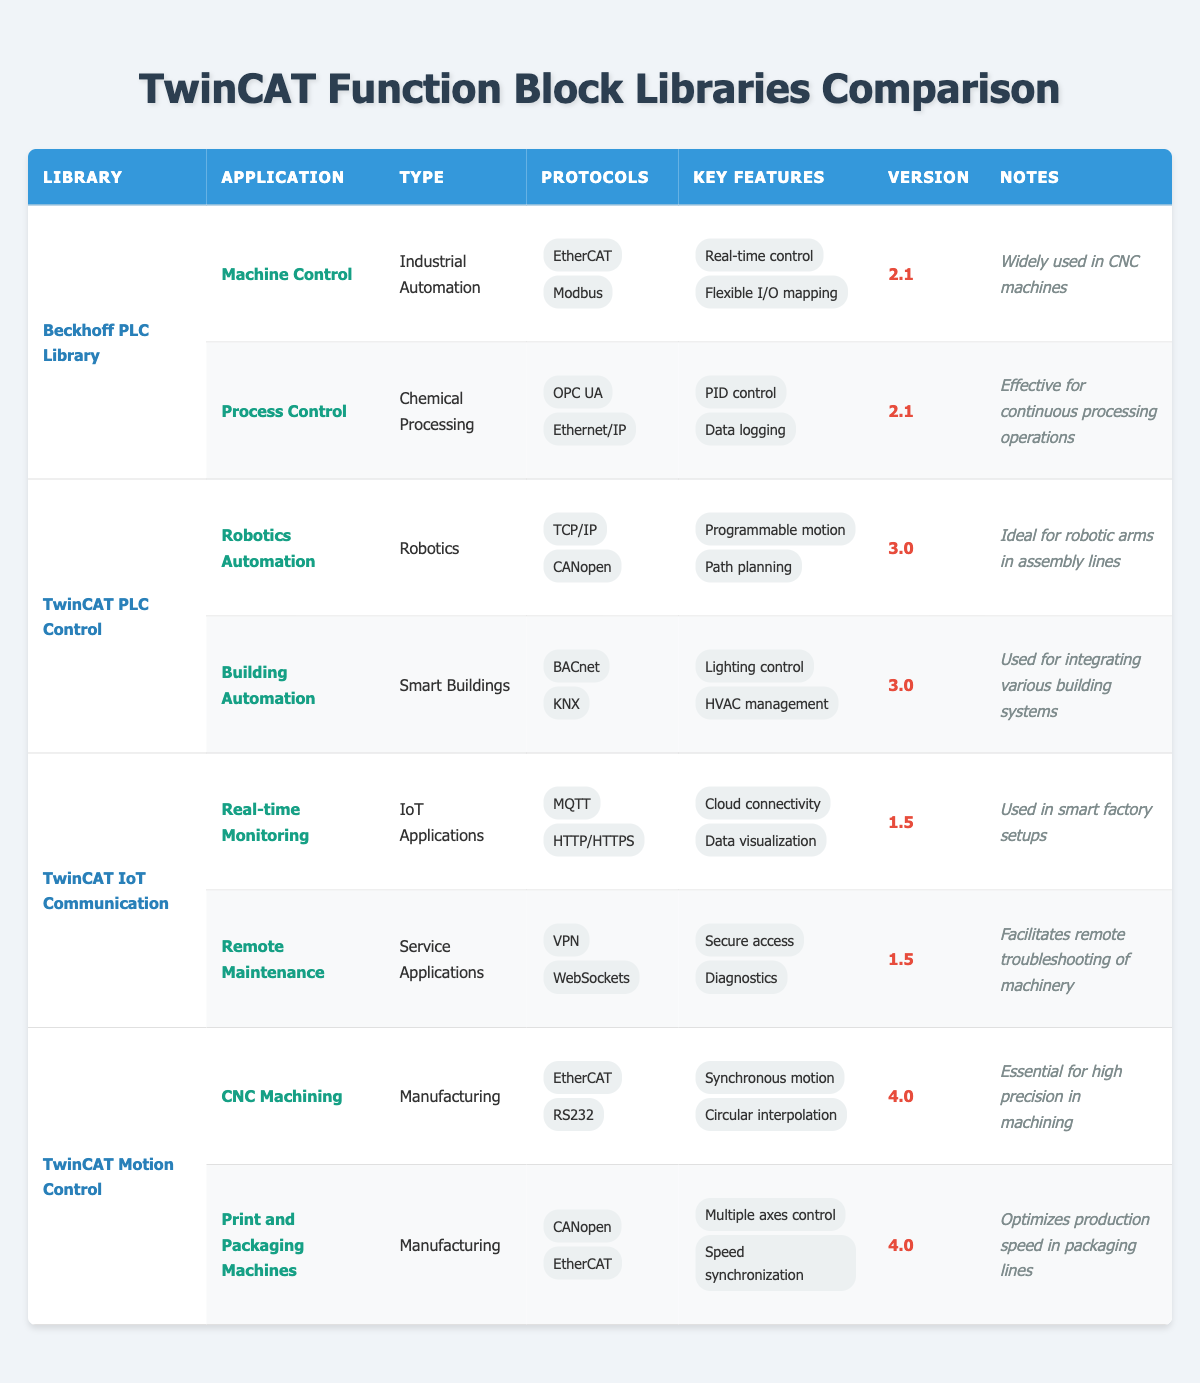What is the main application type for the Beckhoff PLC Library? The Beckhoff PLC Library has two applications listed: "Machine Control" and "Process Control." The application type for both is indicated as "Industrial Automation." Therefore, the main application type for this library is Industrial Automation.
Answer: Industrial Automation Which library supports the protocol "MQTT"? The protocol "MQTT" is listed under the application "Real-time Monitoring" which belongs to the library "TwinCAT IoT Communication." Thus, it is only supported by this library.
Answer: TwinCAT IoT Communication What are the key features of the TwinCAT Motion Control library? The TwinCAT Motion Control library has two applications: "CNC Machining" and "Print and Packaging Machines." The key features listed for these applications are "Synchronous motion" and "Circular interpolation" for CNC Machining, and "Multiple axes control" and "Speed synchronization" for Print and Packaging Machines. Combining these, the key features of the TwinCAT Motion Control library are Synchronous motion, Circular interpolation, Multiple axes control, and Speed synchronization.
Answer: Synchronous motion, Circular interpolation, Multiple axes control, Speed synchronization Is the TwinCAT PLC Control library used for remote maintenance? "Remote Maintenance" is not listed under the TwinCAT PLC Control library; it is actually part of the "TwinCAT IoT Communication" library. Therefore, the TwinCAT PLC Control library is not used for remote maintenance.
Answer: No Which application type is associated with the highest library version? The highest version listed in the table is "4.0," which is associated with both applications under the "TwinCAT Motion Control" library: "CNC Machining" and "Print and Packaging Machines," both categorized under "Manufacturing." Hence, the application type with the highest library version is Manufacturing.
Answer: Manufacturing What is the main function of the TwinCAT IoT Communication library based on its applications? The TwinCAT IoT Communication library includes applications for "Real-time Monitoring" and "Remote Maintenance," indicating that its main functions are related to monitoring and maintaining systems remotely, typically in IoT setups.
Answer: Monitoring and maintenance How many different protocols are supported by all the libraries combined? The following protocols are listed across the libraries: EtherCAT, Modbus, OPC UA, Ethernet/IP, TCP/IP, CANopen, BACnet, KNX, MQTT, HTTP/HTTPS, VPN, WebSockets, RS232. When counted, there are 12 unique protocols in total.
Answer: 12 Which library is aimed at building automation? The application "Building Automation" is specifically listed under the "TwinCAT PLC Control" library, making it the library aimed at building automation.
Answer: TwinCAT PLC Control What are the protocols used in the CNC Machining application? The application "CNC Machining" under the TwinCAT Motion Control library uses the protocols "EtherCAT" and "RS232." Therefore, these are the protocols associated with CNC Machining.
Answer: EtherCAT, RS232 Which function block library has the usage note stating it is "Effective for continuous processing operations"? The usage note "Effective for continuous processing operations" is mentioned for the application "Process Control," which is under the "Beckhoff PLC Library." Therefore, this library has that usage note.
Answer: Beckhoff PLC Library 